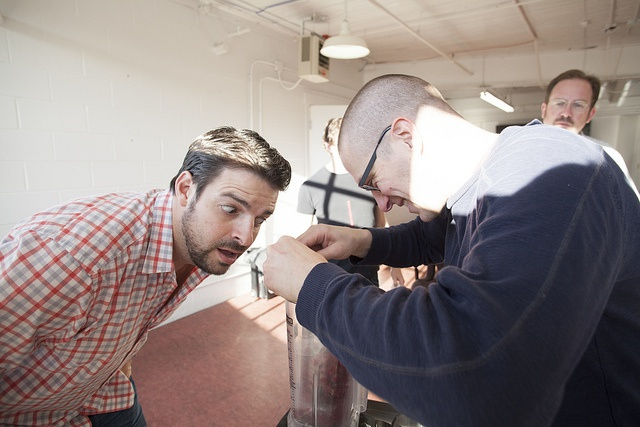Describe the objects in this image and their specific colors. I can see people in darkgray, black, white, and gray tones, people in darkgray, gray, and lightgray tones, people in darkgray, lightgray, gray, and tan tones, and people in darkgray, tan, and gray tones in this image. 